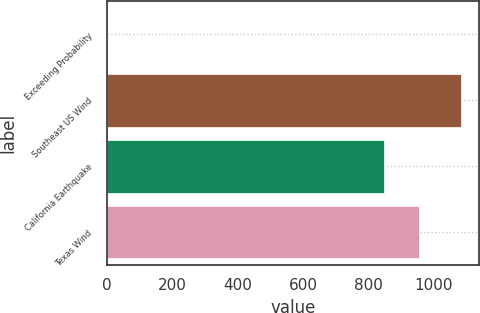<chart> <loc_0><loc_0><loc_500><loc_500><bar_chart><fcel>Exceeding Probability<fcel>Southeast US Wind<fcel>California Earthquake<fcel>Texas Wind<nl><fcel>0.4<fcel>1083<fcel>846<fcel>954.26<nl></chart> 